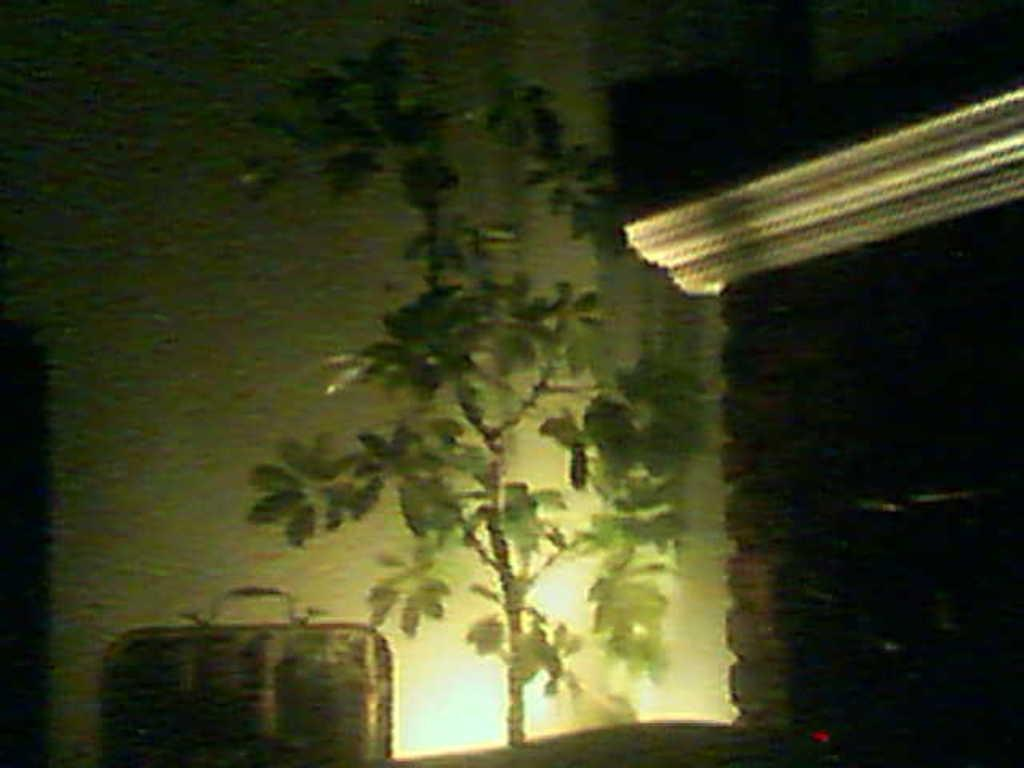What is located in the middle of the image? There is a plant and a suitcase in the middle of the image. What can be seen behind the plant and suitcase? There is a wall visible in the image. How many tomatoes are hanging on the calendar in the hospital room? There is no calendar or hospital room present in the image; it features a plant, a suitcase, and a wall. 